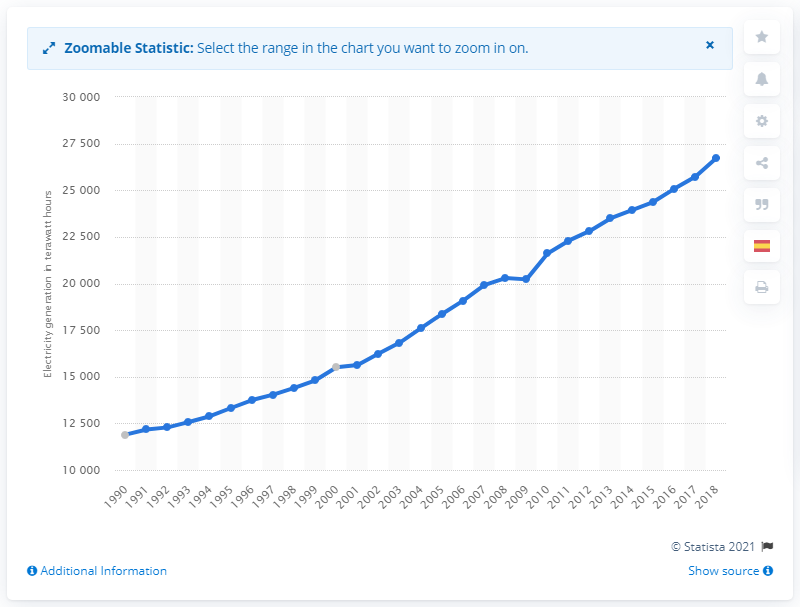Outline some significant characteristics in this image. In 2009, electricity generation fell. 